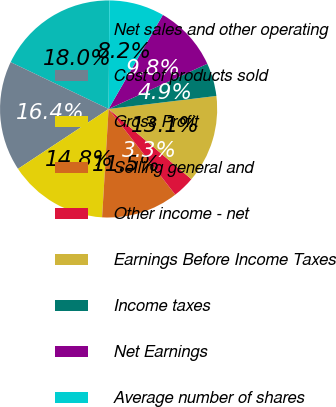Convert chart to OTSL. <chart><loc_0><loc_0><loc_500><loc_500><pie_chart><fcel>Net sales and other operating<fcel>Cost of products sold<fcel>Gross Profit<fcel>Selling general and<fcel>Other income - net<fcel>Earnings Before Income Taxes<fcel>Income taxes<fcel>Net Earnings<fcel>Average number of shares<nl><fcel>18.03%<fcel>16.39%<fcel>14.75%<fcel>11.48%<fcel>3.28%<fcel>13.11%<fcel>4.92%<fcel>9.84%<fcel>8.2%<nl></chart> 